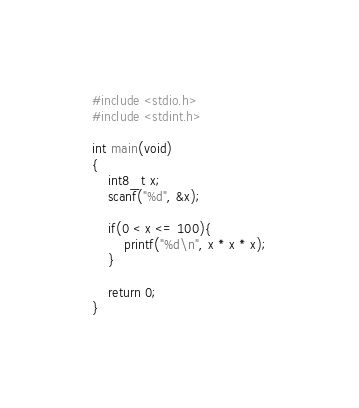Convert code to text. <code><loc_0><loc_0><loc_500><loc_500><_C_>#include <stdio.h>
#include <stdint.h>

int main(void)
{
    int8_t x;
    scanf("%d", &x);

    if(0 < x <= 100){
        printf("%d\n", x * x * x);
    }

    return 0;
}
</code> 